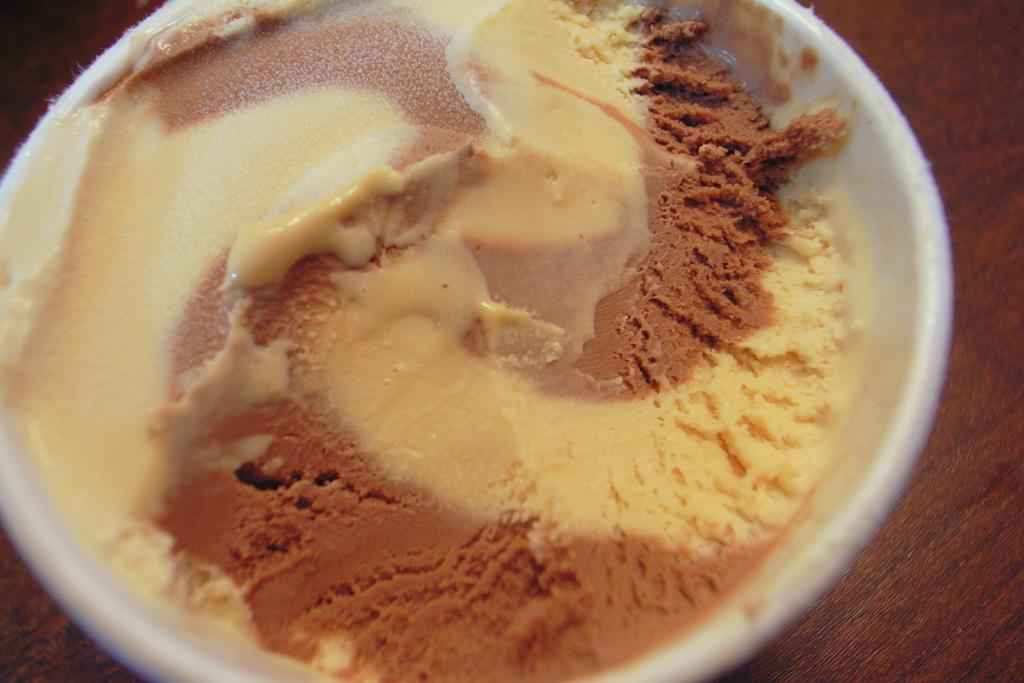What object is present in the image that can hold food? There is a bowl in the image that can hold food. What type of food is in the bowl? The bowl contains food, but the specific type of food is not mentioned in the facts. What kind of surprise is hidden in the bowl? There is no mention of a surprise or anything hidden in the bowl in the provided facts. 